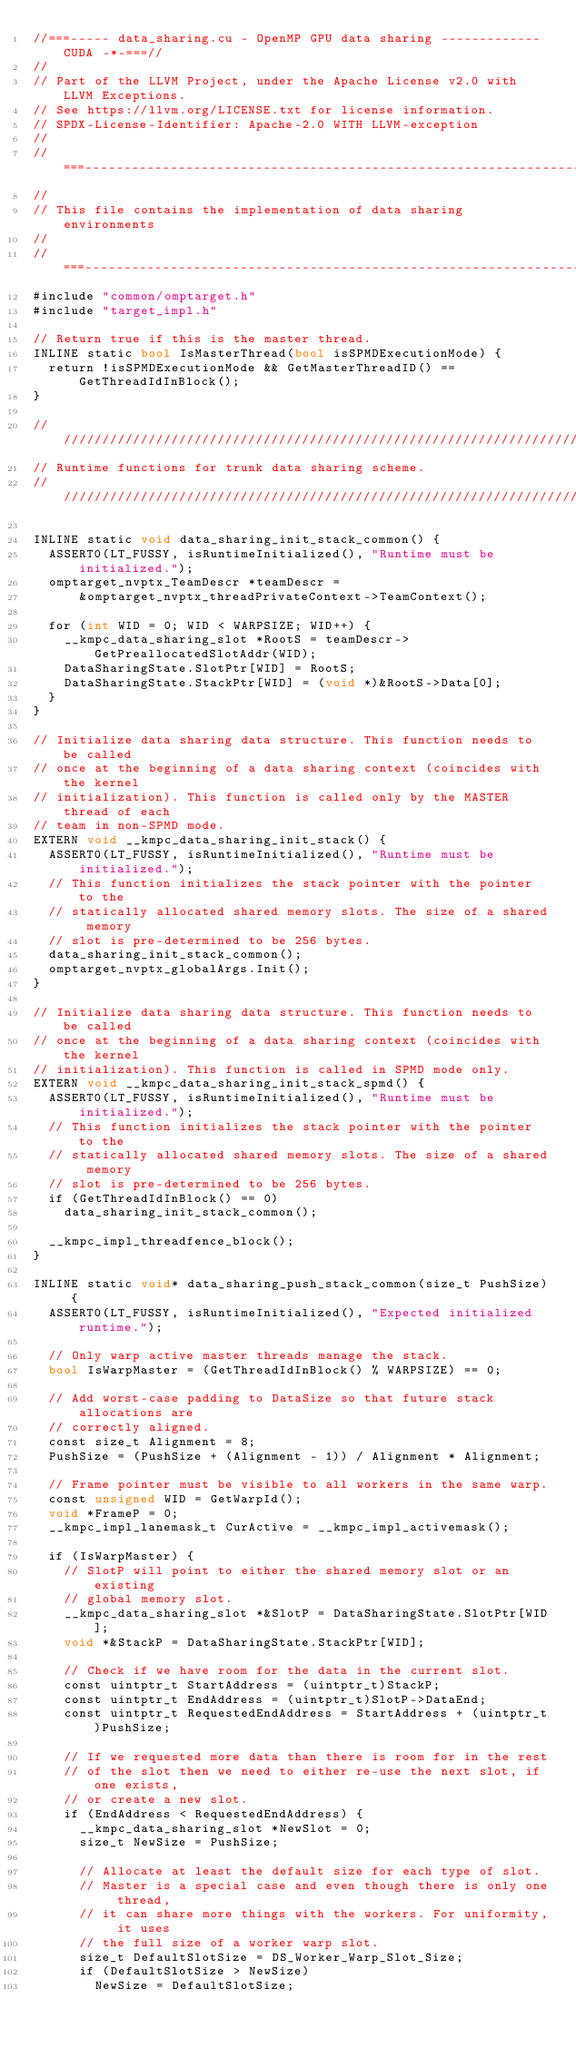Convert code to text. <code><loc_0><loc_0><loc_500><loc_500><_Cuda_>//===----- data_sharing.cu - OpenMP GPU data sharing ------------- CUDA -*-===//
//
// Part of the LLVM Project, under the Apache License v2.0 with LLVM Exceptions.
// See https://llvm.org/LICENSE.txt for license information.
// SPDX-License-Identifier: Apache-2.0 WITH LLVM-exception
//
//===----------------------------------------------------------------------===//
//
// This file contains the implementation of data sharing environments
//
//===----------------------------------------------------------------------===//
#include "common/omptarget.h"
#include "target_impl.h"

// Return true if this is the master thread.
INLINE static bool IsMasterThread(bool isSPMDExecutionMode) {
  return !isSPMDExecutionMode && GetMasterThreadID() == GetThreadIdInBlock();
}

////////////////////////////////////////////////////////////////////////////////
// Runtime functions for trunk data sharing scheme.
////////////////////////////////////////////////////////////////////////////////

INLINE static void data_sharing_init_stack_common() {
  ASSERT0(LT_FUSSY, isRuntimeInitialized(), "Runtime must be initialized.");
  omptarget_nvptx_TeamDescr *teamDescr =
      &omptarget_nvptx_threadPrivateContext->TeamContext();

  for (int WID = 0; WID < WARPSIZE; WID++) {
    __kmpc_data_sharing_slot *RootS = teamDescr->GetPreallocatedSlotAddr(WID);
    DataSharingState.SlotPtr[WID] = RootS;
    DataSharingState.StackPtr[WID] = (void *)&RootS->Data[0];
  }
}

// Initialize data sharing data structure. This function needs to be called
// once at the beginning of a data sharing context (coincides with the kernel
// initialization). This function is called only by the MASTER thread of each
// team in non-SPMD mode.
EXTERN void __kmpc_data_sharing_init_stack() {
  ASSERT0(LT_FUSSY, isRuntimeInitialized(), "Runtime must be initialized.");
  // This function initializes the stack pointer with the pointer to the
  // statically allocated shared memory slots. The size of a shared memory
  // slot is pre-determined to be 256 bytes.
  data_sharing_init_stack_common();
  omptarget_nvptx_globalArgs.Init();
}

// Initialize data sharing data structure. This function needs to be called
// once at the beginning of a data sharing context (coincides with the kernel
// initialization). This function is called in SPMD mode only.
EXTERN void __kmpc_data_sharing_init_stack_spmd() {
  ASSERT0(LT_FUSSY, isRuntimeInitialized(), "Runtime must be initialized.");
  // This function initializes the stack pointer with the pointer to the
  // statically allocated shared memory slots. The size of a shared memory
  // slot is pre-determined to be 256 bytes.
  if (GetThreadIdInBlock() == 0)
    data_sharing_init_stack_common();

  __kmpc_impl_threadfence_block();
}

INLINE static void* data_sharing_push_stack_common(size_t PushSize) {
  ASSERT0(LT_FUSSY, isRuntimeInitialized(), "Expected initialized runtime.");

  // Only warp active master threads manage the stack.
  bool IsWarpMaster = (GetThreadIdInBlock() % WARPSIZE) == 0;

  // Add worst-case padding to DataSize so that future stack allocations are
  // correctly aligned.
  const size_t Alignment = 8;
  PushSize = (PushSize + (Alignment - 1)) / Alignment * Alignment;

  // Frame pointer must be visible to all workers in the same warp.
  const unsigned WID = GetWarpId();
  void *FrameP = 0;
  __kmpc_impl_lanemask_t CurActive = __kmpc_impl_activemask();

  if (IsWarpMaster) {
    // SlotP will point to either the shared memory slot or an existing
    // global memory slot.
    __kmpc_data_sharing_slot *&SlotP = DataSharingState.SlotPtr[WID];
    void *&StackP = DataSharingState.StackPtr[WID];

    // Check if we have room for the data in the current slot.
    const uintptr_t StartAddress = (uintptr_t)StackP;
    const uintptr_t EndAddress = (uintptr_t)SlotP->DataEnd;
    const uintptr_t RequestedEndAddress = StartAddress + (uintptr_t)PushSize;

    // If we requested more data than there is room for in the rest
    // of the slot then we need to either re-use the next slot, if one exists,
    // or create a new slot.
    if (EndAddress < RequestedEndAddress) {
      __kmpc_data_sharing_slot *NewSlot = 0;
      size_t NewSize = PushSize;

      // Allocate at least the default size for each type of slot.
      // Master is a special case and even though there is only one thread,
      // it can share more things with the workers. For uniformity, it uses
      // the full size of a worker warp slot.
      size_t DefaultSlotSize = DS_Worker_Warp_Slot_Size;
      if (DefaultSlotSize > NewSize)
        NewSize = DefaultSlotSize;</code> 